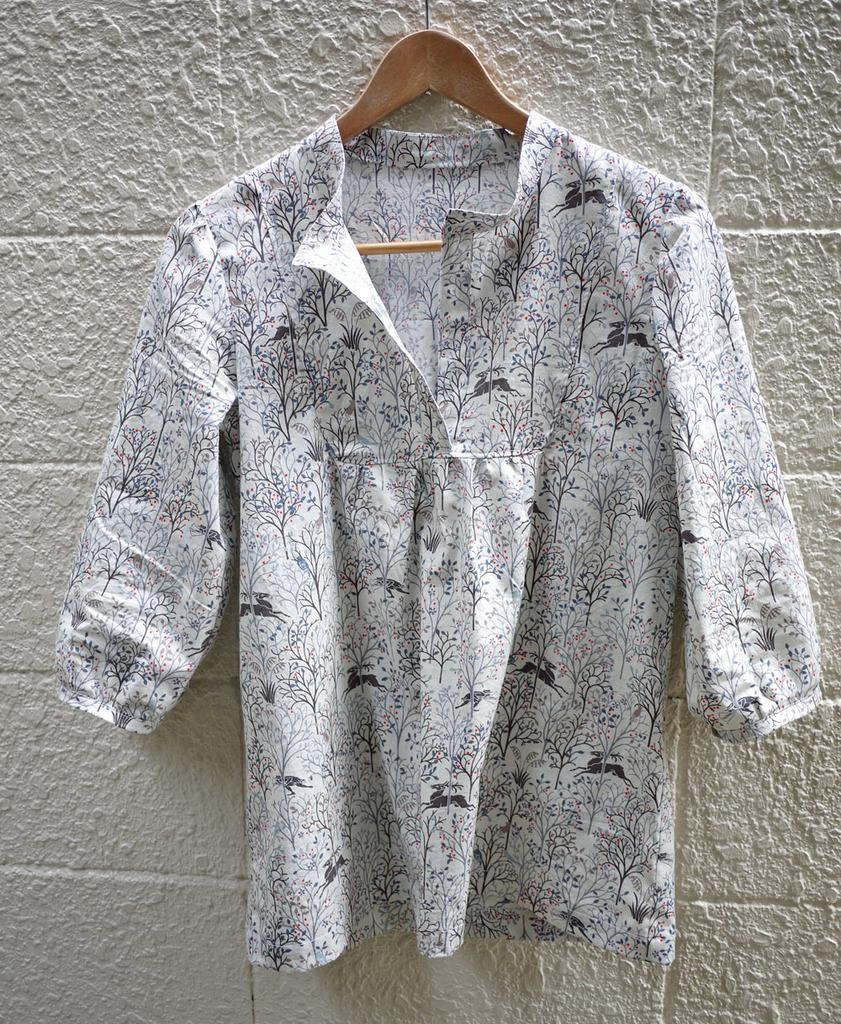What object is present in the image that is used for hanging clothes? There is a hanger in the image. What is the color of the hanger? The hanger is brown in color. What type of dress is hanging on the hanger? There is a white and black colored dress hanged on the hanger. What can be seen in the background of the image? There is a white colored wall in the background of the image. What type of breakfast is being prepared in the image? There is no breakfast preparation visible in the image. What is the price of the dress hanging on the hanger? The price of the dress is not mentioned in the image. 